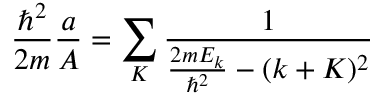Convert formula to latex. <formula><loc_0><loc_0><loc_500><loc_500>{ \frac { \hbar { ^ } { 2 } } { 2 m } } { \frac { a } { A } } = \sum _ { K } { \frac { 1 } { { \frac { 2 m E _ { k } } { \hbar { ^ } { 2 } } } - ( k + K ) ^ { 2 } } }</formula> 